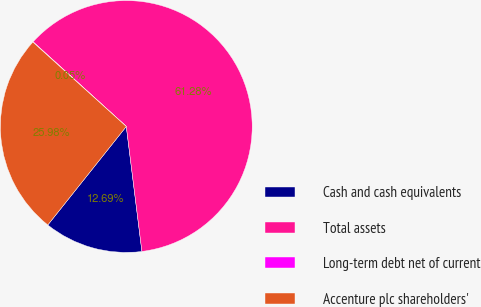Convert chart to OTSL. <chart><loc_0><loc_0><loc_500><loc_500><pie_chart><fcel>Cash and cash equivalents<fcel>Total assets<fcel>Long-term debt net of current<fcel>Accenture plc shareholders'<nl><fcel>12.69%<fcel>61.28%<fcel>0.05%<fcel>25.98%<nl></chart> 